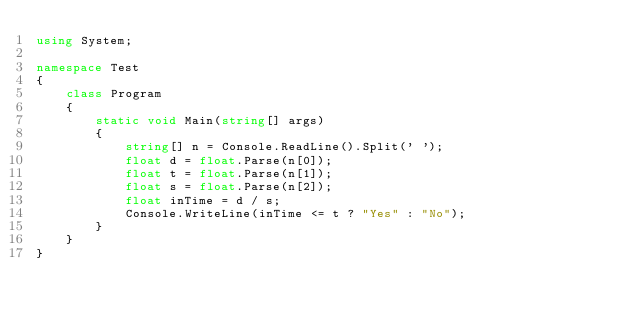Convert code to text. <code><loc_0><loc_0><loc_500><loc_500><_C#_>using System;

namespace Test
{
    class Program
    {
        static void Main(string[] args)
        {
            string[] n = Console.ReadLine().Split(' ');
            float d = float.Parse(n[0]);
            float t = float.Parse(n[1]);
            float s = float.Parse(n[2]);
            float inTime = d / s;
            Console.WriteLine(inTime <= t ? "Yes" : "No");
        }
    }
}</code> 